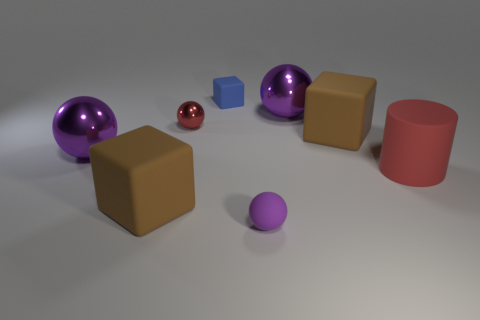There is a shiny object that is the same color as the big rubber cylinder; what is its shape?
Your answer should be very brief. Sphere. How many objects are either small things that are to the right of the small blue matte cube or purple rubber balls?
Give a very brief answer. 1. Does the blue matte cube have the same size as the cylinder?
Your response must be concise. No. There is a matte block that is in front of the rubber cylinder; what is its color?
Your answer should be compact. Brown. The red cylinder that is made of the same material as the small purple sphere is what size?
Your answer should be compact. Large. Is the size of the matte cylinder the same as the brown object behind the red cylinder?
Make the answer very short. Yes. There is a large brown object that is behind the large red rubber cylinder; what is its material?
Keep it short and to the point. Rubber. How many cylinders are in front of the small sphere left of the tiny rubber cube?
Give a very brief answer. 1. Is there a large green rubber object that has the same shape as the large red thing?
Your answer should be compact. No. Do the rubber cube that is in front of the large red object and the brown matte object that is behind the large red cylinder have the same size?
Make the answer very short. Yes. 